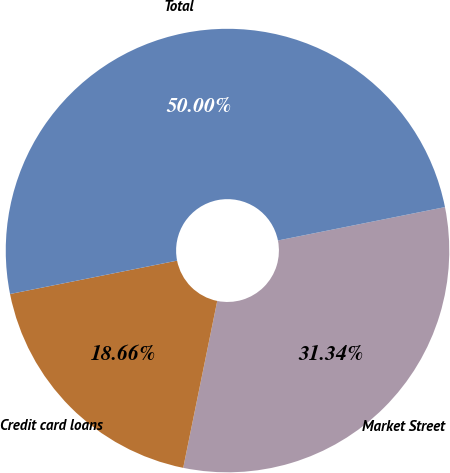Convert chart to OTSL. <chart><loc_0><loc_0><loc_500><loc_500><pie_chart><fcel>Market Street<fcel>Credit card loans<fcel>Total<nl><fcel>31.34%<fcel>18.66%<fcel>50.0%<nl></chart> 